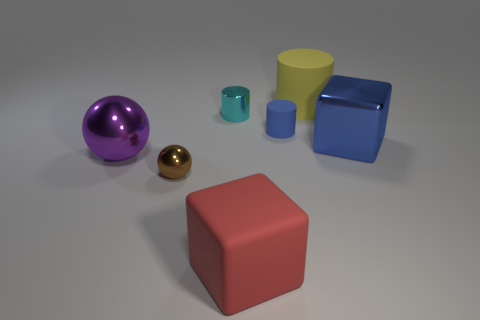If you had to guess, what material do you think each object is made out of? Although it's just a rendering, the objects seem to mimic various materials: the large and small balls have a reflective surface suggesting metallic properties; the red cube looks matte, similar to plastic or painted wood; the yellow cone and turquoise cylinder exhibit a satin finish, possibly representing a ceramic or plastic material; and the blue cube appears to have a slightly glossy finish, like polished plastic or glass. 